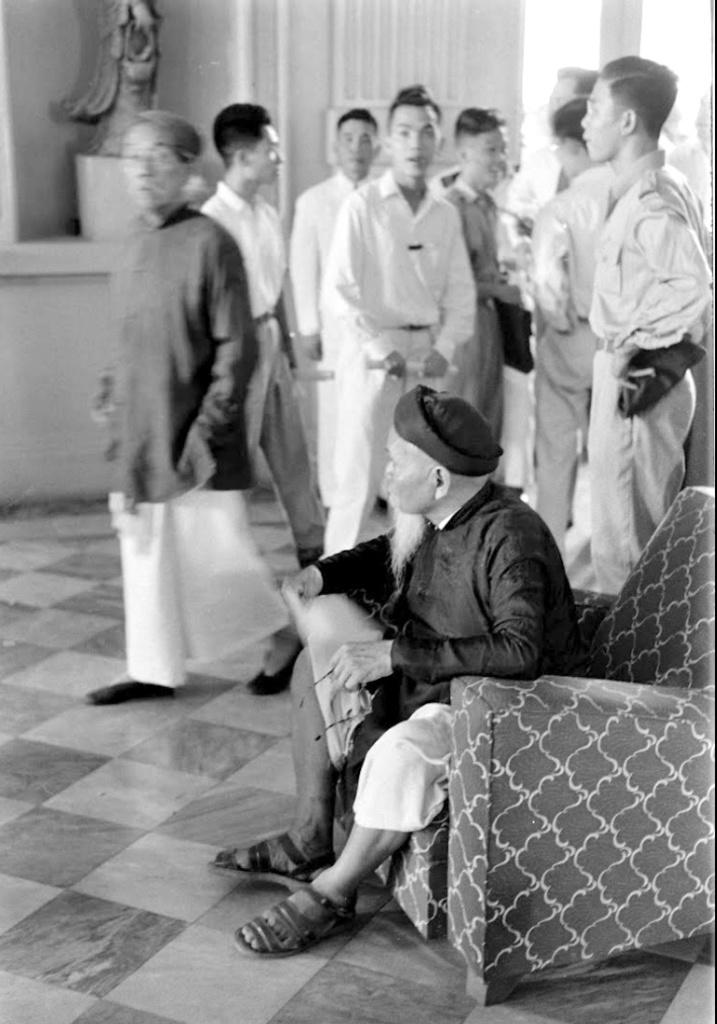What is the man doing in the image? The man is sitting on the sofa on the right side of the image. What can be seen in the background of the image? There are people and a statue in the background of the image. What type of pencil is the man using to swim in the image? There is no pencil or swimming activity present in the image. 